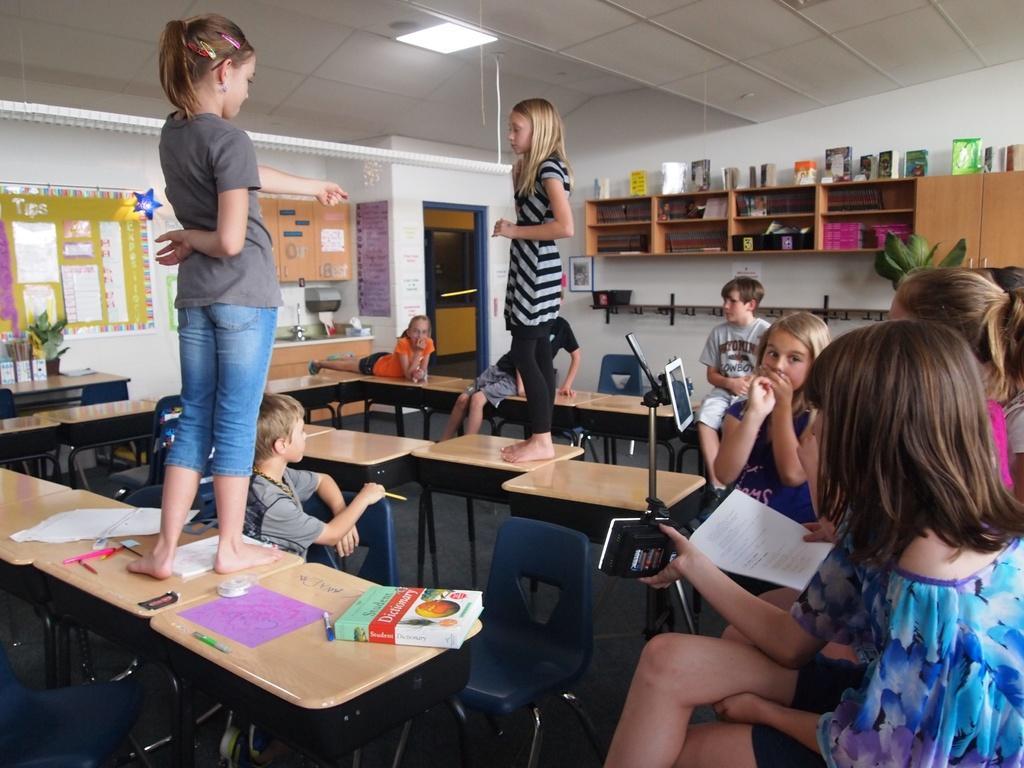Please provide a concise description of this image. In this picture there are some tables which are in yellow color on that tables there are some books, There are some kids sitting on the chairs and there are two girls standing on the table, In the background there is a white color wall and there are some posters pasted and in the top there is a white color roof. 